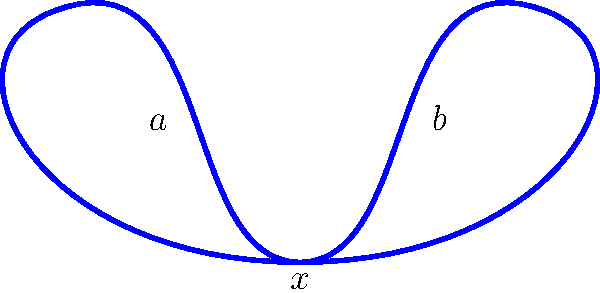Consider the figure-eight space shown above. Determine its fundamental group and express it in terms of free group generators. How does this compare to the fundamental group of a more prestigious space, such as the torus? Let's approach this step-by-step:

1) The figure-eight space consists of two loops joined at a single point. We can view this as the wedge sum of two circles.

2) Each circle contributes one generator to the fundamental group. Let's call these generators $a$ and $b$, corresponding to the left and right loops respectively.

3) The fundamental group of a single circle is isomorphic to $\mathbb{Z}$, the integers under addition.

4) When we take the wedge sum of two circles, the fundamental group becomes the free product of the fundamental groups of each circle.

5) Therefore, the fundamental group of the figure-eight space is the free group on two generators, denoted as $F_2$ or $\langle a, b \rangle$.

6) This means that elements of the group are words in $a$ and $b$, with no relations between them. For example, $aba^{-1}b^2$ is an element of this group.

7) Comparing to the torus: The fundamental group of a torus is $\mathbb{Z} \times \mathbb{Z}$, which is abelian (commutative). In contrast, $F_2$ is non-abelian, making it a "richer" and more complex group structure.

8) The figure-eight space thus has a more intricate fundamental group than the torus, despite the torus being a seemingly more sophisticated space.
Answer: $F_2 = \langle a, b \rangle$ 